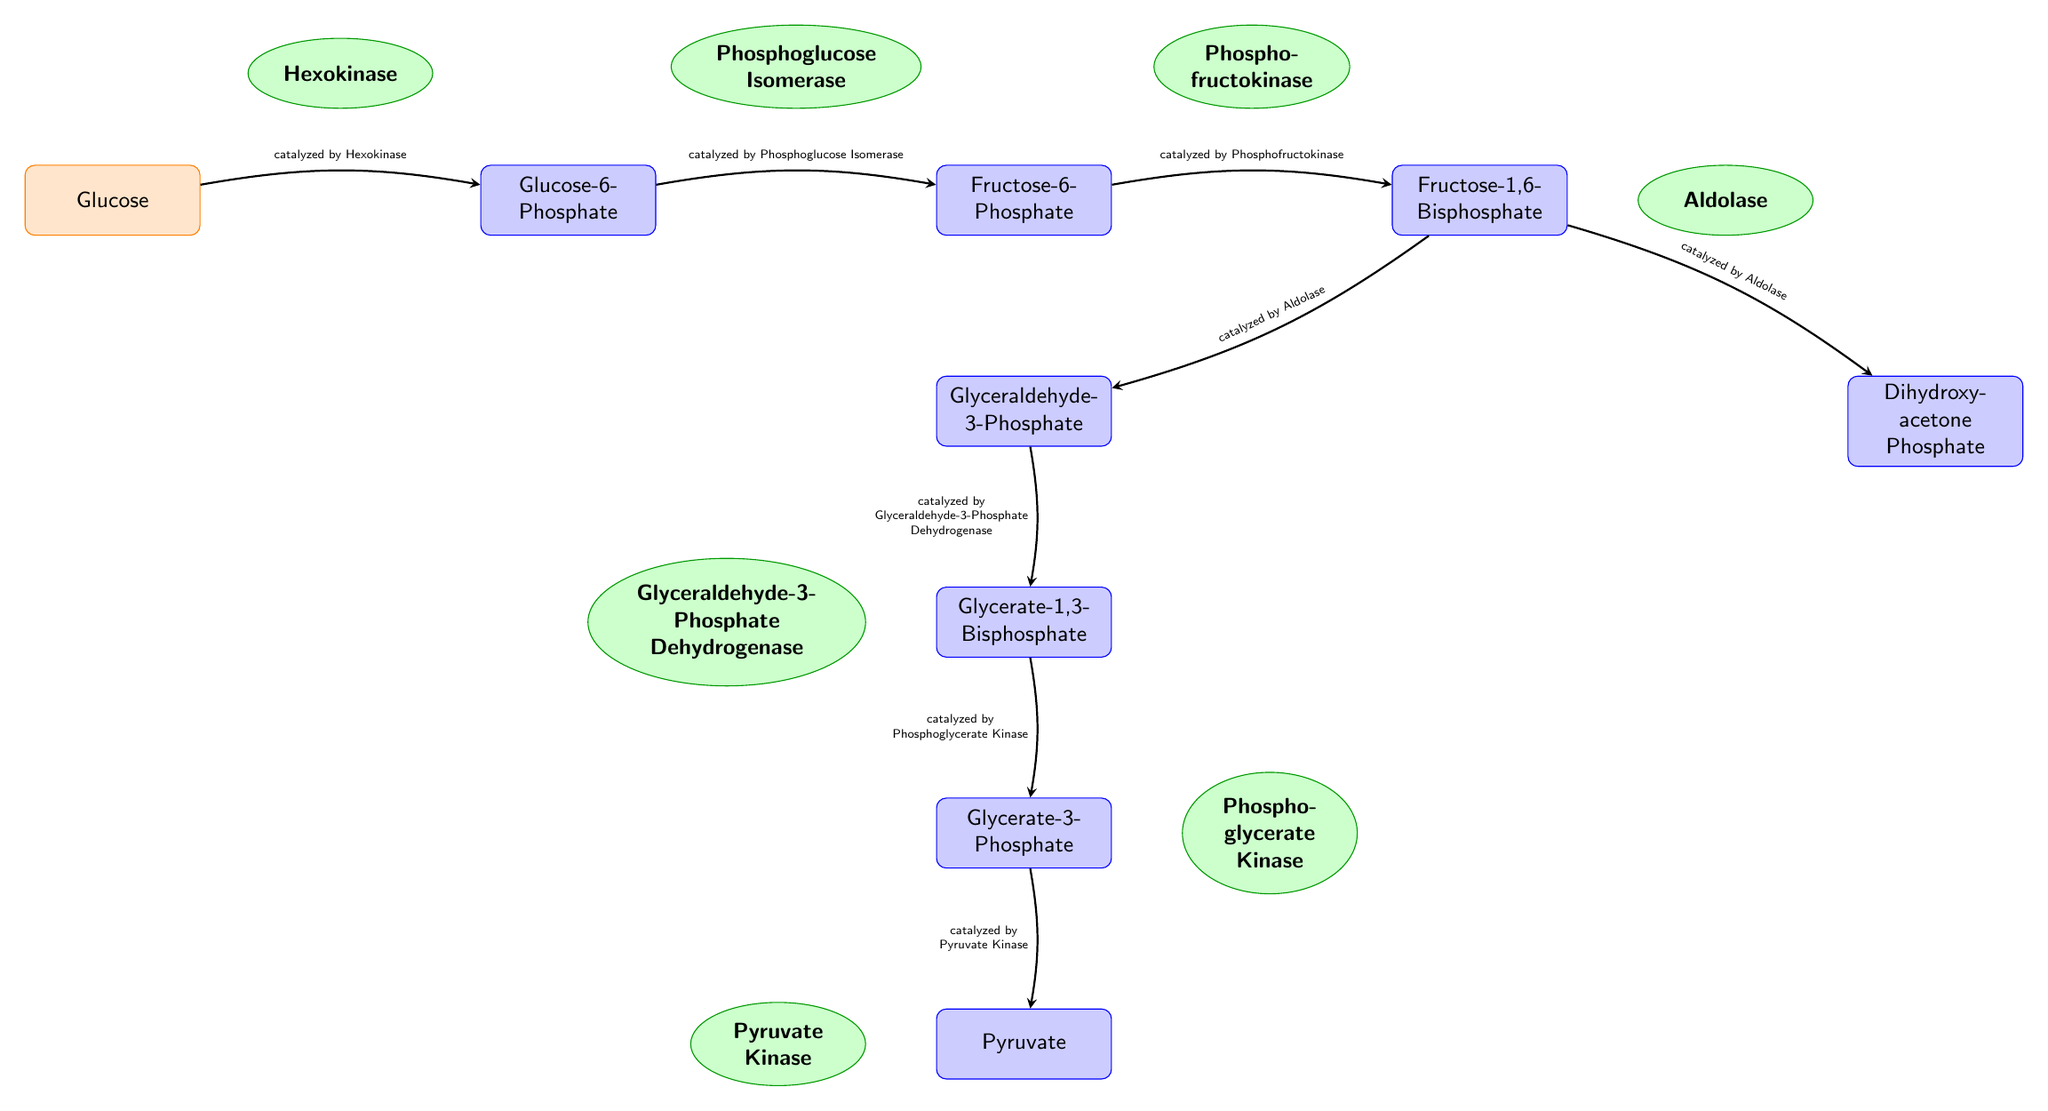What is the first substrate in the metabolic pathway? The diagram identifies the first substrate as Glucose, which is the starting point of the enzyme-catalyzed reactions.
Answer: Glucose How many products are generated after the conversion of Glucose in the diagram? The diagram shows that Glucose is converted into several products. Specifically, after multiple enzyme actions, four products are noted: Glucose-6-Phosphate, Fructose-6-Phosphate, Fructose-1,6-Bisphosphate, and from Fructose-1,6-Bisphosphate, two products: Dihydroxy-acetone Phosphate and Glyceraldehyde-3-Phosphate. So there are a total of 6 products identified overall.
Answer: 6 Which enzyme catalyzes the conversion of Fructose-6-Phosphate to Fructose-1,6-Bisphosphate? The diagram indicates that the conversion from Fructose-6-Phosphate to Fructose-1,6-Bisphosphate is catalyzed by Phosphofructokinase.
Answer: Phosphofructokinase What is the final product produced in this metabolic pathway? The diagram specifies that the final product generated in the pathway is Pyruvate, which is reached at the end of the sequence.
Answer: Pyruvate Which two products emerge from Fructose-1,6-Bisphosphate? Looking at the diagram, we see that Fructose-1,6-Bisphosphate leads to two distinct products: Dihydroxy-acetone Phosphate and Glyceraldehyde-3-Phosphate.
Answer: Dihydroxy-acetone Phosphate, Glyceraldehyde-3-Phosphate How many enzymes are involved in this metabolic pathway? By analyzing the diagram, we count the enzymes listed: Hexokinase, Phosphoglucose Isomerase, Phosphofructokinase, Aldolase, Glyceraldehyde-3-Phosphate Dehydrogenase, Phosphoglycerate Kinase, and Pyruvate Kinase, making a total of 7 enzymes involved in the pathway.
Answer: 7 What type of flow direction does this diagram illustrate? The arrows in the diagram indicate a left-to-right flow of information through the metabolic pathway, illustrating the conversion of substrates to products through various enzyme reactions.
Answer: Left-to-right 